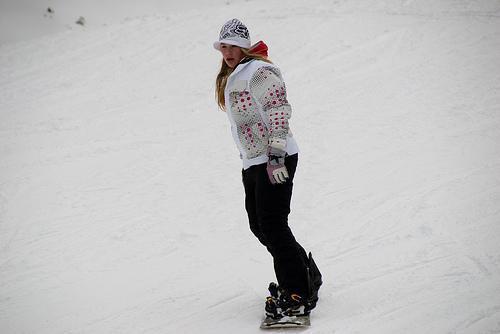How many people are in the photo?
Give a very brief answer. 1. 